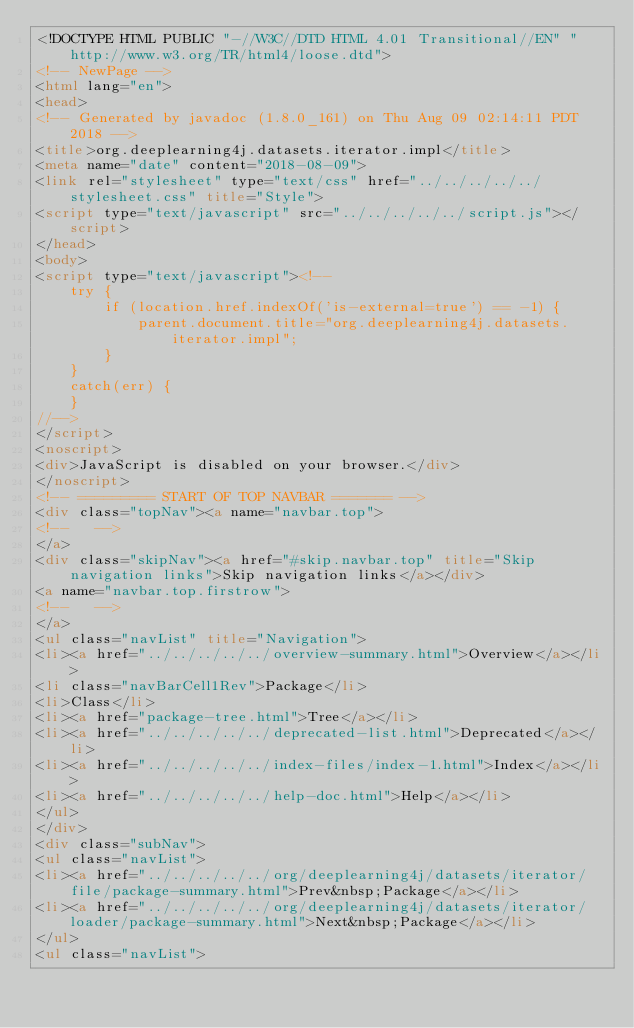<code> <loc_0><loc_0><loc_500><loc_500><_HTML_><!DOCTYPE HTML PUBLIC "-//W3C//DTD HTML 4.01 Transitional//EN" "http://www.w3.org/TR/html4/loose.dtd">
<!-- NewPage -->
<html lang="en">
<head>
<!-- Generated by javadoc (1.8.0_161) on Thu Aug 09 02:14:11 PDT 2018 -->
<title>org.deeplearning4j.datasets.iterator.impl</title>
<meta name="date" content="2018-08-09">
<link rel="stylesheet" type="text/css" href="../../../../../stylesheet.css" title="Style">
<script type="text/javascript" src="../../../../../script.js"></script>
</head>
<body>
<script type="text/javascript"><!--
    try {
        if (location.href.indexOf('is-external=true') == -1) {
            parent.document.title="org.deeplearning4j.datasets.iterator.impl";
        }
    }
    catch(err) {
    }
//-->
</script>
<noscript>
<div>JavaScript is disabled on your browser.</div>
</noscript>
<!-- ========= START OF TOP NAVBAR ======= -->
<div class="topNav"><a name="navbar.top">
<!--   -->
</a>
<div class="skipNav"><a href="#skip.navbar.top" title="Skip navigation links">Skip navigation links</a></div>
<a name="navbar.top.firstrow">
<!--   -->
</a>
<ul class="navList" title="Navigation">
<li><a href="../../../../../overview-summary.html">Overview</a></li>
<li class="navBarCell1Rev">Package</li>
<li>Class</li>
<li><a href="package-tree.html">Tree</a></li>
<li><a href="../../../../../deprecated-list.html">Deprecated</a></li>
<li><a href="../../../../../index-files/index-1.html">Index</a></li>
<li><a href="../../../../../help-doc.html">Help</a></li>
</ul>
</div>
<div class="subNav">
<ul class="navList">
<li><a href="../../../../../org/deeplearning4j/datasets/iterator/file/package-summary.html">Prev&nbsp;Package</a></li>
<li><a href="../../../../../org/deeplearning4j/datasets/iterator/loader/package-summary.html">Next&nbsp;Package</a></li>
</ul>
<ul class="navList"></code> 